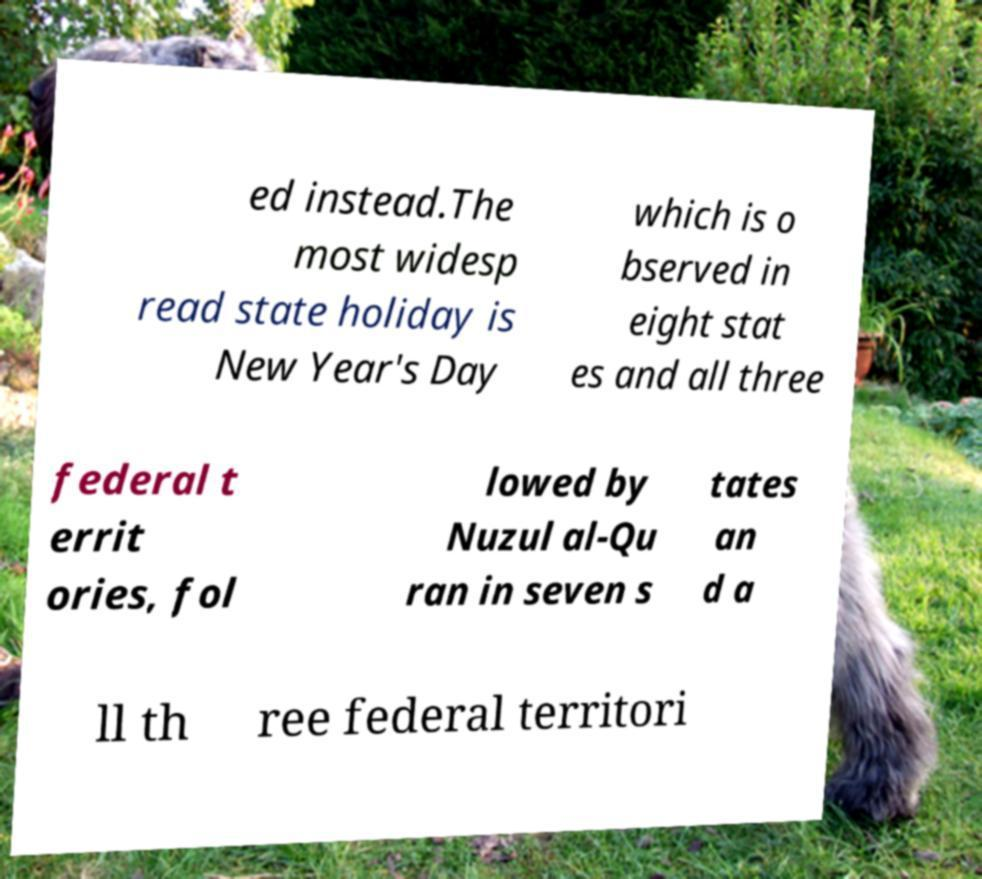Can you read and provide the text displayed in the image?This photo seems to have some interesting text. Can you extract and type it out for me? ed instead.The most widesp read state holiday is New Year's Day which is o bserved in eight stat es and all three federal t errit ories, fol lowed by Nuzul al-Qu ran in seven s tates an d a ll th ree federal territori 